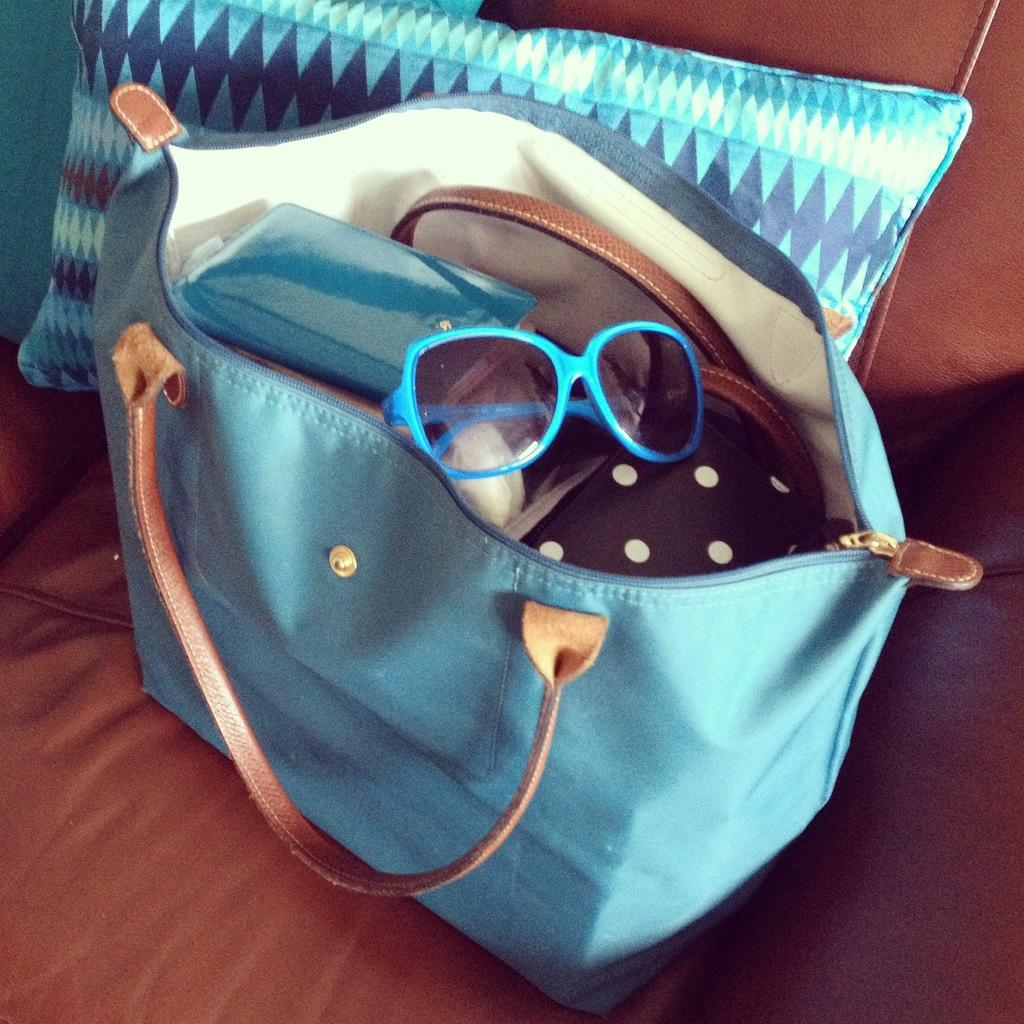What object is present in the image that people might use to carry items? There is a bag in the image. What is the color of the bag? The bag is blue in color. What other item can be seen in the image? There are spectacles in the image. What type of wood can be seen growing in the image? There is no wood or trees visible in the image; it only features a bag and spectacles. 